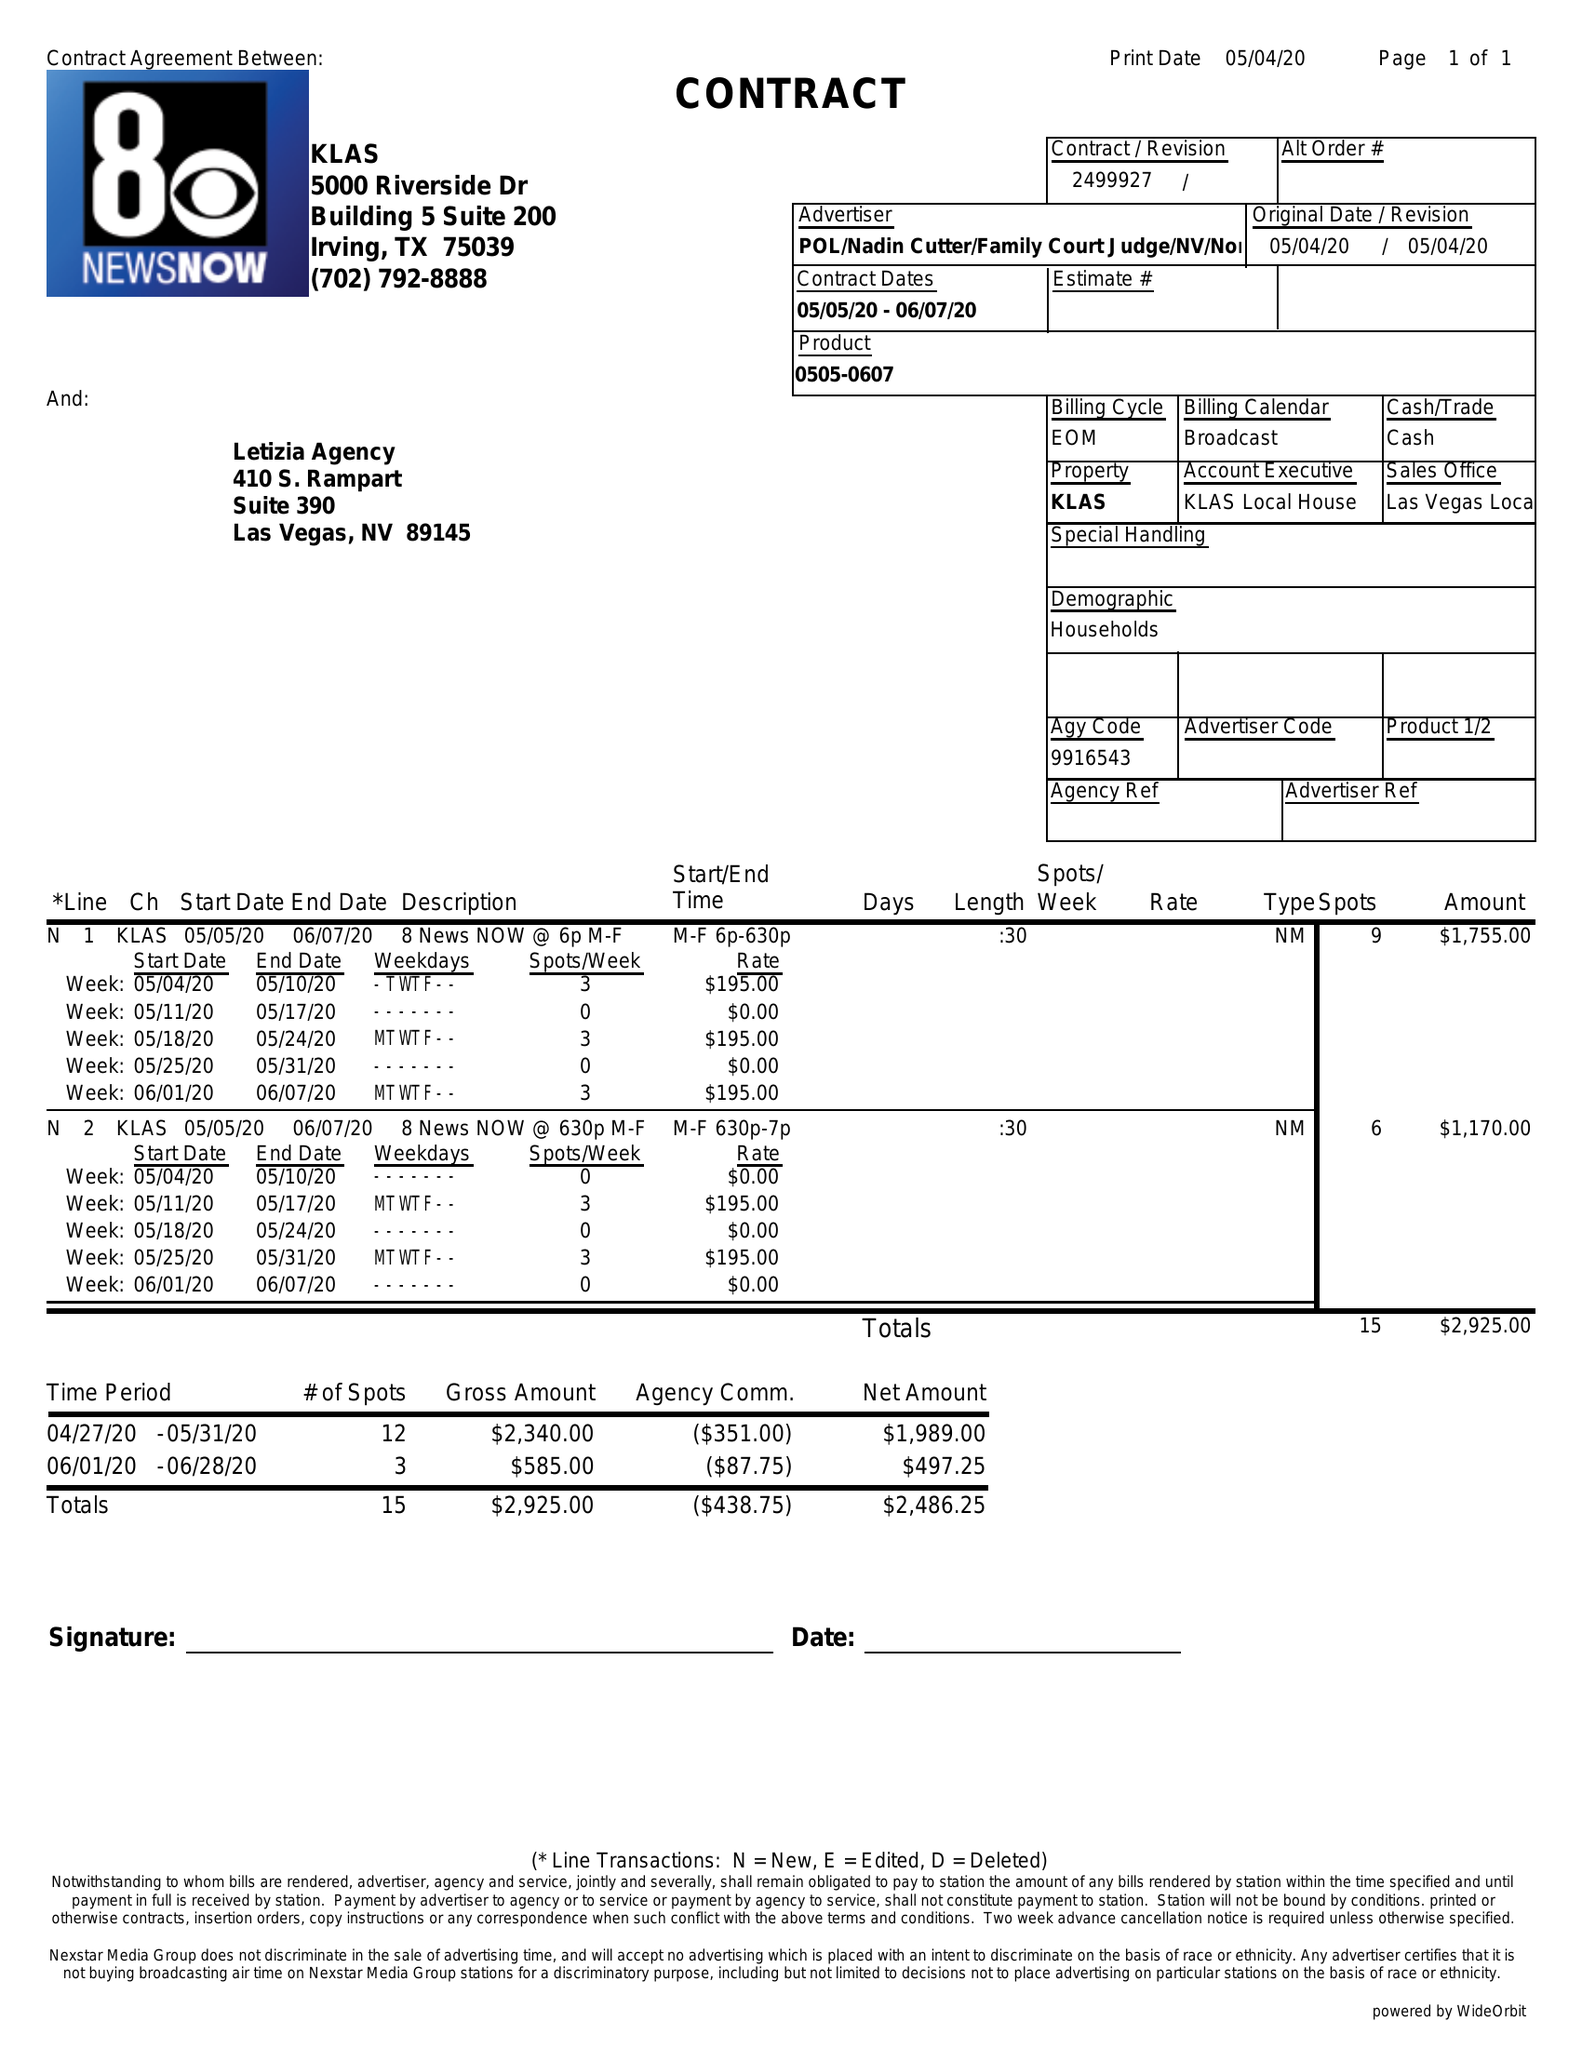What is the value for the contract_num?
Answer the question using a single word or phrase. 2499927 